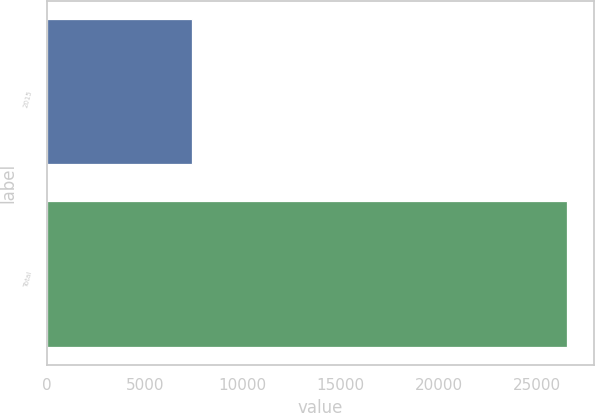Convert chart to OTSL. <chart><loc_0><loc_0><loc_500><loc_500><bar_chart><fcel>2015<fcel>Total<nl><fcel>7394<fcel>26557<nl></chart> 